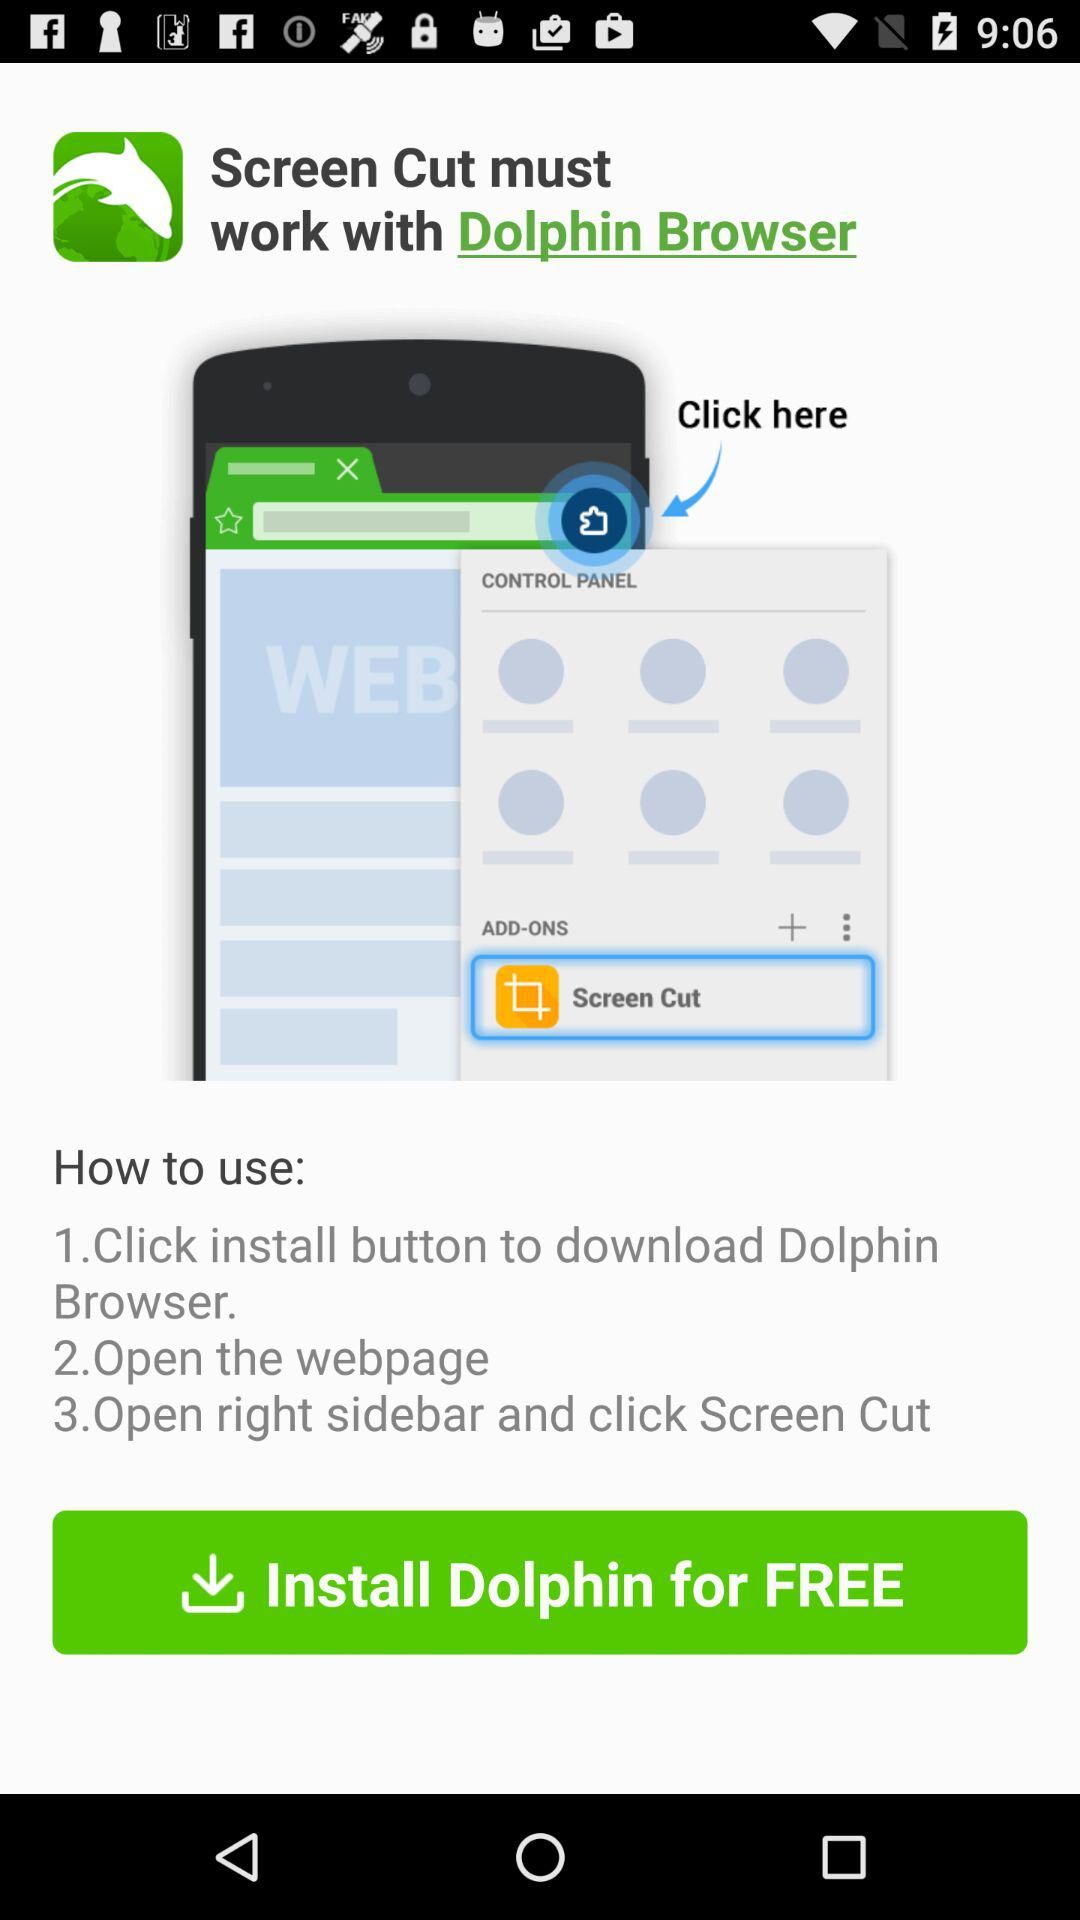How many steps are in the instructions?
Answer the question using a single word or phrase. 3 